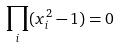<formula> <loc_0><loc_0><loc_500><loc_500>\prod _ { i } ( x _ { i } ^ { 2 } - 1 ) = 0</formula> 